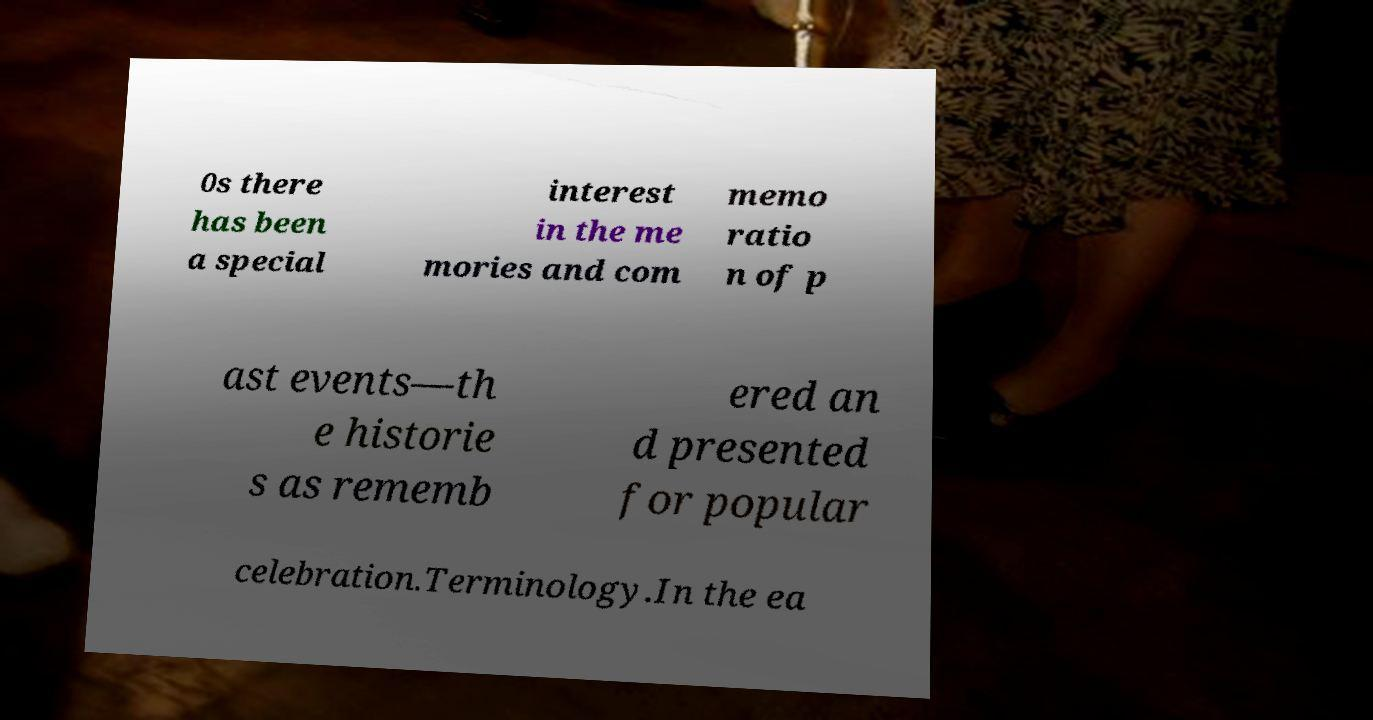There's text embedded in this image that I need extracted. Can you transcribe it verbatim? 0s there has been a special interest in the me mories and com memo ratio n of p ast events—th e historie s as rememb ered an d presented for popular celebration.Terminology.In the ea 